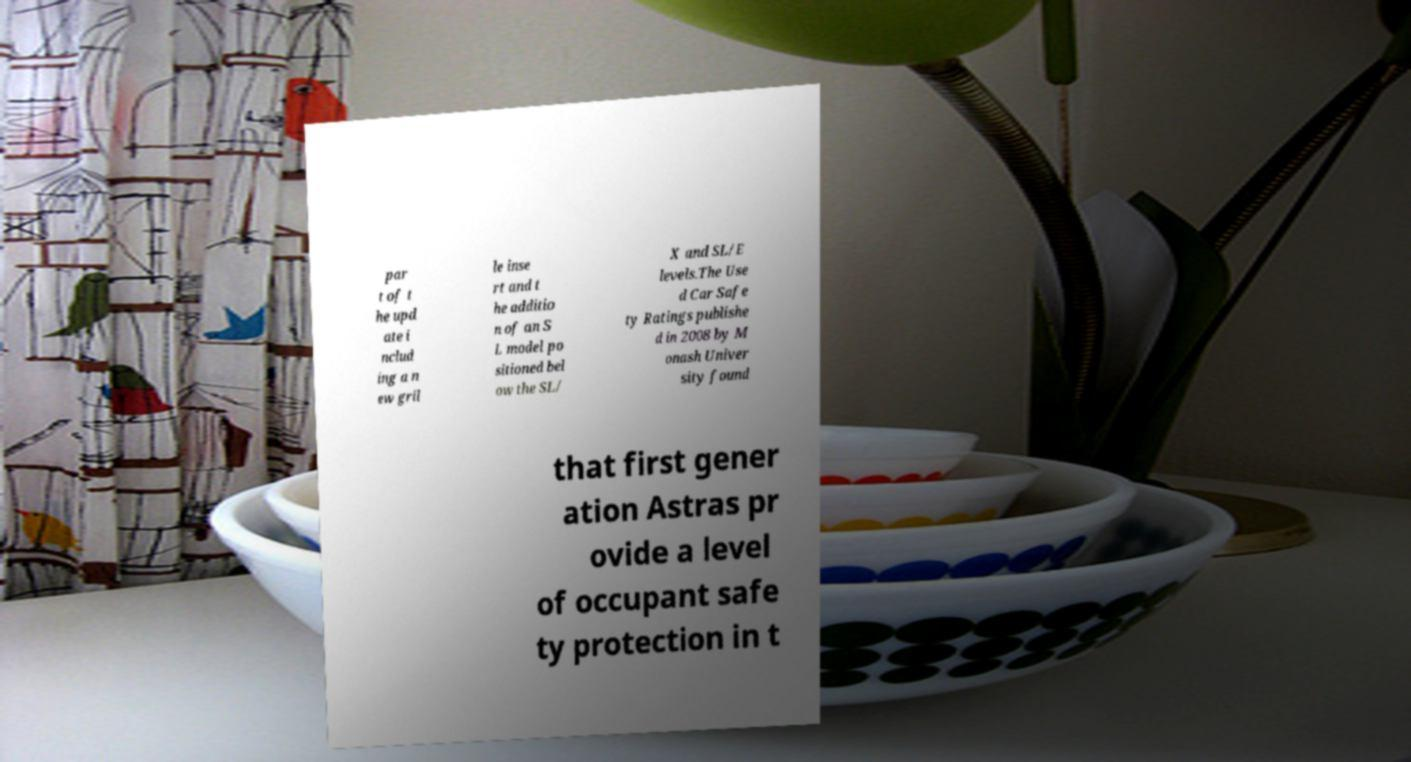What messages or text are displayed in this image? I need them in a readable, typed format. par t of t he upd ate i nclud ing a n ew gril le inse rt and t he additio n of an S L model po sitioned bel ow the SL/ X and SL/E levels.The Use d Car Safe ty Ratings publishe d in 2008 by M onash Univer sity found that first gener ation Astras pr ovide a level of occupant safe ty protection in t 